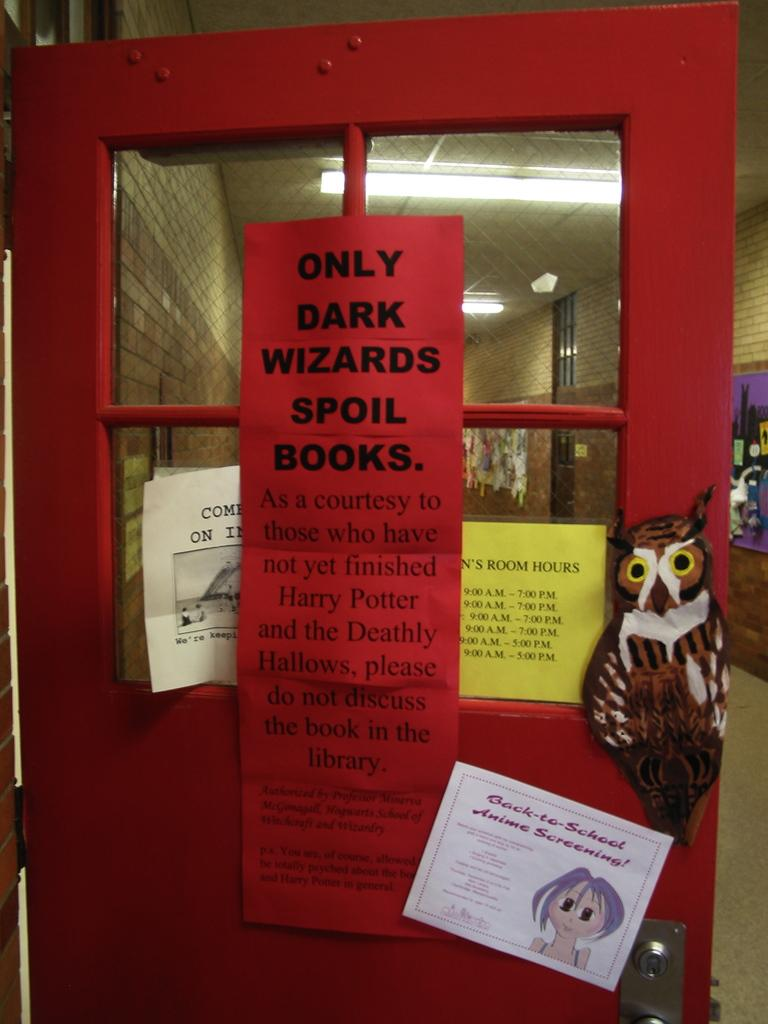<image>
Give a short and clear explanation of the subsequent image. The read sign is asking that those who have finished reading Harry Potter and the Deathly Hallows to please do not discuss the book in the library. 